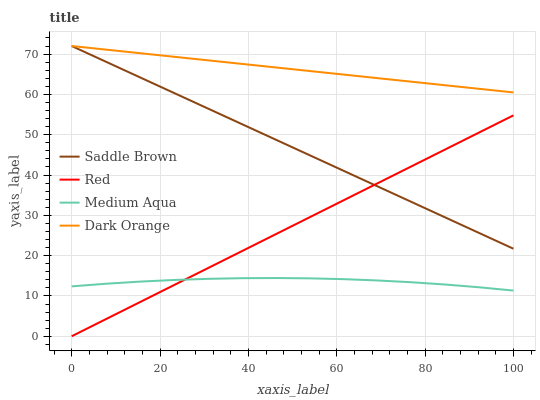Does Medium Aqua have the minimum area under the curve?
Answer yes or no. Yes. Does Dark Orange have the maximum area under the curve?
Answer yes or no. Yes. Does Saddle Brown have the minimum area under the curve?
Answer yes or no. No. Does Saddle Brown have the maximum area under the curve?
Answer yes or no. No. Is Red the smoothest?
Answer yes or no. Yes. Is Medium Aqua the roughest?
Answer yes or no. Yes. Is Saddle Brown the smoothest?
Answer yes or no. No. Is Saddle Brown the roughest?
Answer yes or no. No. Does Medium Aqua have the lowest value?
Answer yes or no. No. Does Saddle Brown have the highest value?
Answer yes or no. Yes. Does Medium Aqua have the highest value?
Answer yes or no. No. Is Red less than Dark Orange?
Answer yes or no. Yes. Is Dark Orange greater than Red?
Answer yes or no. Yes. Does Dark Orange intersect Saddle Brown?
Answer yes or no. Yes. Is Dark Orange less than Saddle Brown?
Answer yes or no. No. Is Dark Orange greater than Saddle Brown?
Answer yes or no. No. Does Red intersect Dark Orange?
Answer yes or no. No. 